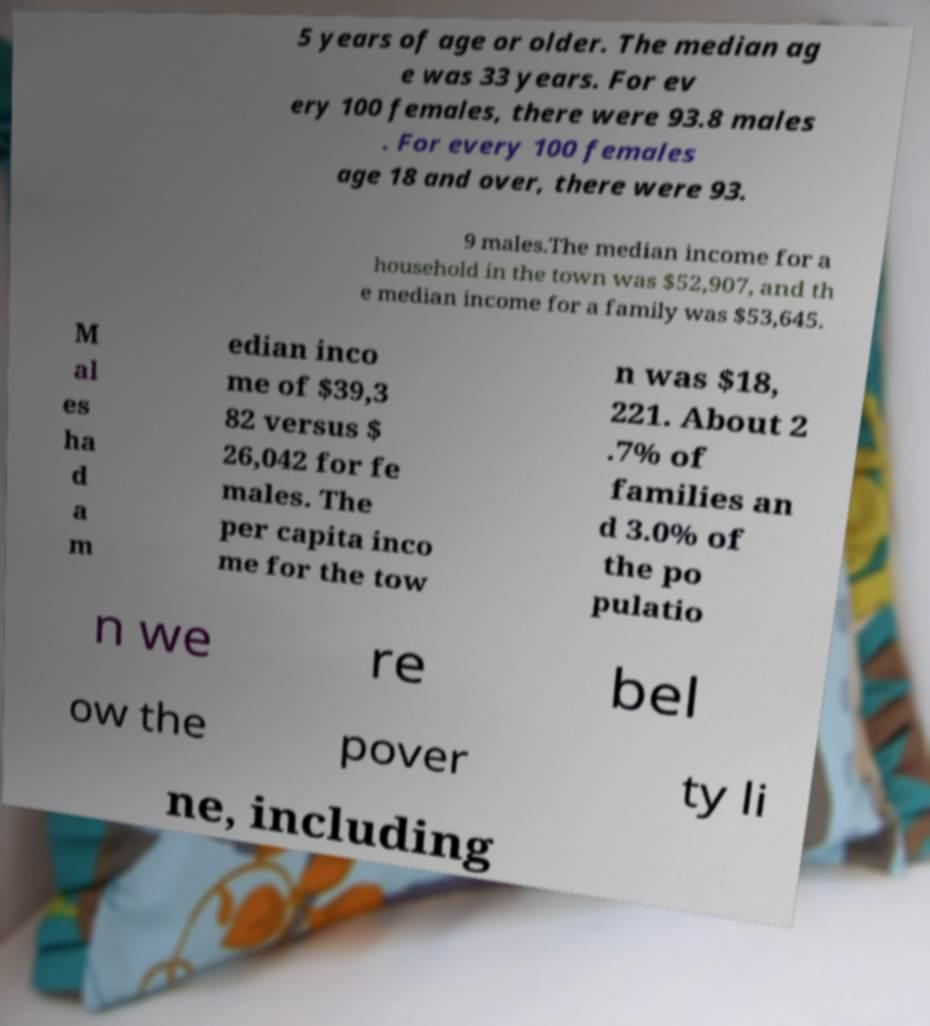Please read and relay the text visible in this image. What does it say? 5 years of age or older. The median ag e was 33 years. For ev ery 100 females, there were 93.8 males . For every 100 females age 18 and over, there were 93. 9 males.The median income for a household in the town was $52,907, and th e median income for a family was $53,645. M al es ha d a m edian inco me of $39,3 82 versus $ 26,042 for fe males. The per capita inco me for the tow n was $18, 221. About 2 .7% of families an d 3.0% of the po pulatio n we re bel ow the pover ty li ne, including 